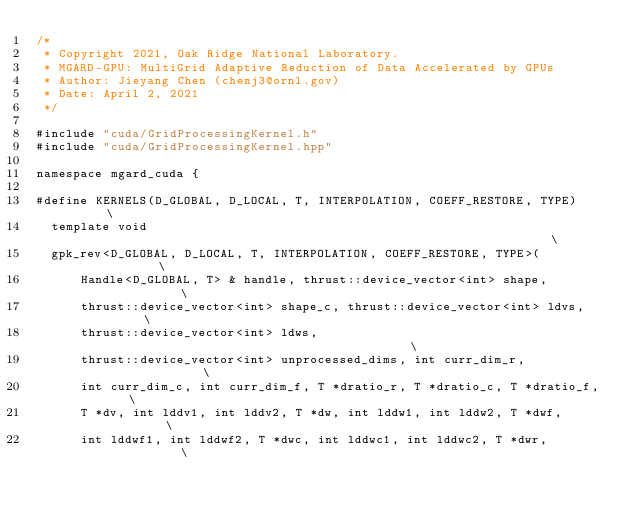<code> <loc_0><loc_0><loc_500><loc_500><_Cuda_>/*
 * Copyright 2021, Oak Ridge National Laboratory.
 * MGARD-GPU: MultiGrid Adaptive Reduction of Data Accelerated by GPUs
 * Author: Jieyang Chen (chenj3@ornl.gov)
 * Date: April 2, 2021
 */

#include "cuda/GridProcessingKernel.h"
#include "cuda/GridProcessingKernel.hpp"

namespace mgard_cuda {

#define KERNELS(D_GLOBAL, D_LOCAL, T, INTERPOLATION, COEFF_RESTORE, TYPE)      \
  template void                                                                \
  gpk_rev<D_GLOBAL, D_LOCAL, T, INTERPOLATION, COEFF_RESTORE, TYPE>(           \
      Handle<D_GLOBAL, T> & handle, thrust::device_vector<int> shape,          \
      thrust::device_vector<int> shape_c, thrust::device_vector<int> ldvs,     \
      thrust::device_vector<int> ldws,                                         \
      thrust::device_vector<int> unprocessed_dims, int curr_dim_r,             \
      int curr_dim_c, int curr_dim_f, T *dratio_r, T *dratio_c, T *dratio_f,   \
      T *dv, int lddv1, int lddv2, T *dw, int lddw1, int lddw2, T *dwf,        \
      int lddwf1, int lddwf2, T *dwc, int lddwc1, int lddwc2, T *dwr,          \</code> 